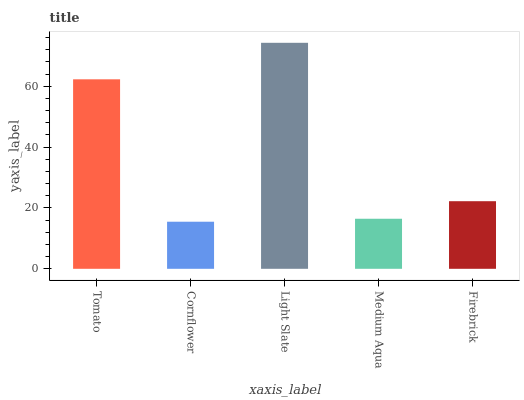Is Cornflower the minimum?
Answer yes or no. Yes. Is Light Slate the maximum?
Answer yes or no. Yes. Is Light Slate the minimum?
Answer yes or no. No. Is Cornflower the maximum?
Answer yes or no. No. Is Light Slate greater than Cornflower?
Answer yes or no. Yes. Is Cornflower less than Light Slate?
Answer yes or no. Yes. Is Cornflower greater than Light Slate?
Answer yes or no. No. Is Light Slate less than Cornflower?
Answer yes or no. No. Is Firebrick the high median?
Answer yes or no. Yes. Is Firebrick the low median?
Answer yes or no. Yes. Is Cornflower the high median?
Answer yes or no. No. Is Tomato the low median?
Answer yes or no. No. 